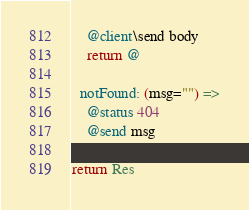Convert code to text. <code><loc_0><loc_0><loc_500><loc_500><_MoonScript_>    @client\send body
    return @

  notFound: (msg="") =>
    @status 404
    @send msg
    
return Res
</code> 